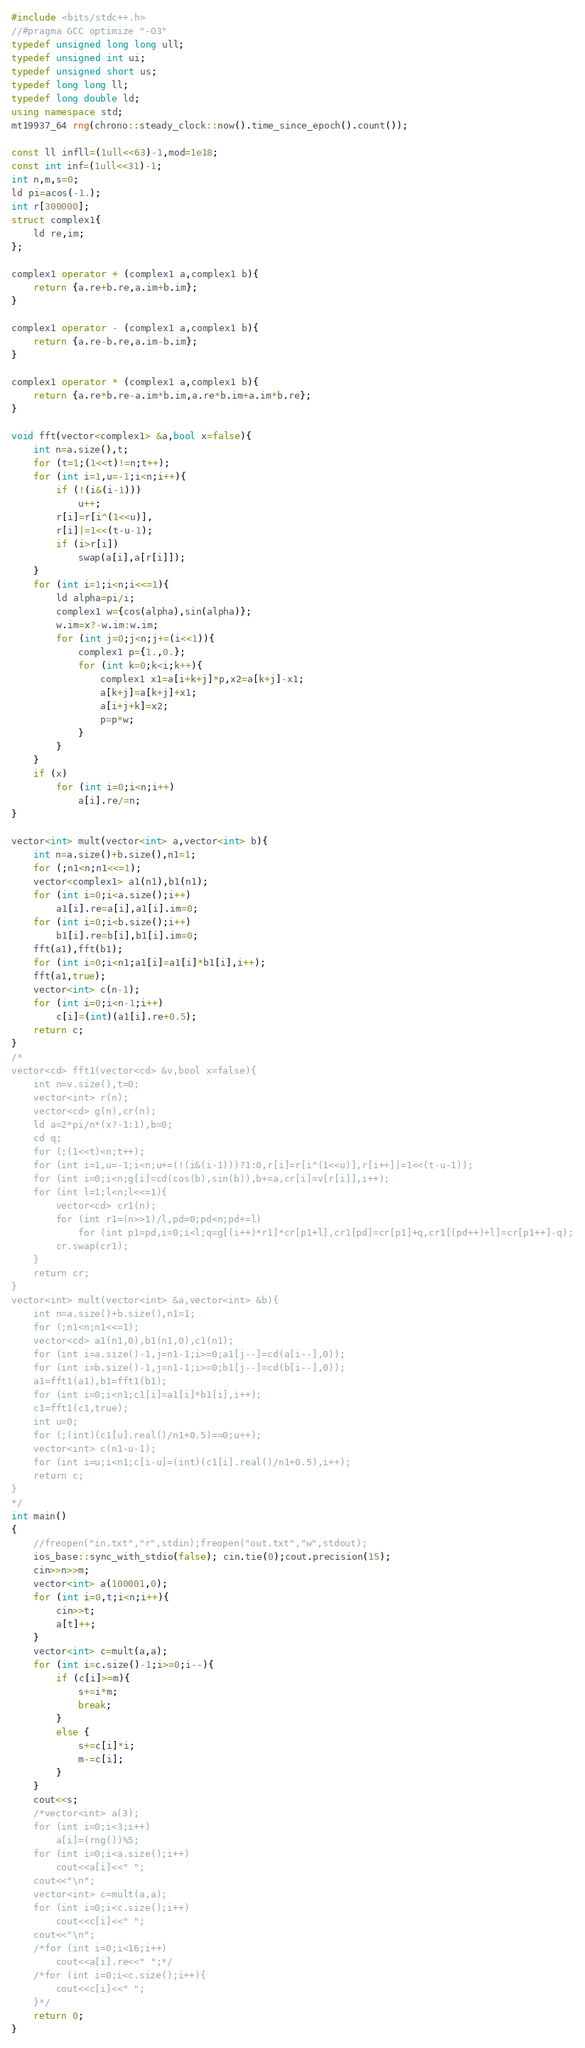Convert code to text. <code><loc_0><loc_0><loc_500><loc_500><_C++_>#include <bits/stdc++.h>
//#pragma GCC optimize "-O3"
typedef unsigned long long ull;
typedef unsigned int ui;
typedef unsigned short us;
typedef long long ll;
typedef long double ld;
using namespace std;
mt19937_64 rng(chrono::steady_clock::now().time_since_epoch().count());

const ll infll=(1ull<<63)-1,mod=1e18;
const int inf=(1ull<<31)-1;
int n,m,s=0;
ld pi=acos(-1.);
int r[300000];
struct complex1{
	ld re,im;
};

complex1 operator + (complex1 a,complex1 b){
	return {a.re+b.re,a.im+b.im};
}

complex1 operator - (complex1 a,complex1 b){
	return {a.re-b.re,a.im-b.im};
}

complex1 operator * (complex1 a,complex1 b){
	return {a.re*b.re-a.im*b.im,a.re*b.im+a.im*b.re};
}

void fft(vector<complex1> &a,bool x=false){
	int n=a.size(),t;
	for (t=1;(1<<t)!=n;t++);
	for (int i=1,u=-1;i<n;i++){
		if (!(i&(i-1)))
			u++;
		r[i]=r[i^(1<<u)],
		r[i]|=1<<(t-u-1);
		if (i>r[i])
			swap(a[i],a[r[i]]);
	}
	for (int i=1;i<n;i<<=1){
		ld alpha=pi/i;
		complex1 w={cos(alpha),sin(alpha)};
		w.im=x?-w.im:w.im;
		for (int j=0;j<n;j+=(i<<1)){
			complex1 p={1.,0.};
			for (int k=0;k<i;k++){
				complex1 x1=a[i+k+j]*p,x2=a[k+j]-x1;
				a[k+j]=a[k+j]+x1;
				a[i+j+k]=x2;
				p=p*w;
			}
		}
	}
	if (x)
		for (int i=0;i<n;i++)
			a[i].re/=n;
}

vector<int> mult(vector<int> a,vector<int> b){
	int n=a.size()+b.size(),n1=1;
	for (;n1<n;n1<<=1);
	vector<complex1> a1(n1),b1(n1);
	for (int i=0;i<a.size();i++)
		a1[i].re=a[i],a1[i].im=0;
	for (int i=0;i<b.size();i++)
		b1[i].re=b[i],b1[i].im=0;
	fft(a1),fft(b1);
	for (int i=0;i<n1;a1[i]=a1[i]*b1[i],i++);
	fft(a1,true);
	vector<int> c(n-1);
	for (int i=0;i<n-1;i++)
		c[i]=(int)(a1[i].re+0.5);
	return c;
}
/*
vector<cd> fft1(vector<cd> &v,bool x=false){
	int n=v.size(),t=0;
	vector<int> r(n);
	vector<cd> g(n),cr(n);
    ld a=2*pi/n*(x?-1:1),b=0;
    cd q;
	for (;(1<<t)<n;t++);
	for (int i=1,u=-1;i<n;u+=(!(i&(i-1)))?1:0,r[i]=r[i^(1<<u)],r[i++]|=1<<(t-u-1));
    for (int i=0;i<n;g[i]=cd(cos(b),sin(b)),b+=a,cr[i]=v[r[i]],i++);
    for (int l=1;l<n;l<<=1){
    	vector<cd> cr1(n);
    	for (int r1=(n>>1)/l,pd=0;pd<n;pd+=l)
    		for (int p1=pd,i=0;i<l;q=g[(i++)*r1]*cr[p1+l],cr1[pd]=cr[p1]+q,cr1[(pd++)+l]=cr[p1++]-q);
    	cr.swap(cr1);
    }
    return cr;
}
vector<int> mult(vector<int> &a,vector<int> &b){
	int n=a.size()+b.size(),n1=1;
	for (;n1<n;n1<<=1);
	vector<cd> a1(n1,0),b1(n1,0),c1(n1);
	for (int i=a.size()-1,j=n1-1;i>=0;a1[j--]=cd(a[i--],0));
	for (int i=b.size()-1,j=n1-1;i>=0;b1[j--]=cd(b[i--],0));
	a1=fft1(a1),b1=fft1(b1);
	for (int i=0;i<n1;c1[i]=a1[i]*b1[i],i++);
	c1=fft1(c1,true);
	int u=0; 
	for (;(int)(c1[u].real()/n1+0.5)==0;u++);
	vector<int> c(n1-u-1);
	for (int i=u;i<n1;c[i-u]=(int)(c1[i].real()/n1+0.5),i++);
	return c;
}
*/
int main()
{
	//freopen("in.txt","r",stdin);freopen("out.txt","w",stdout);
	ios_base::sync_with_stdio(false); cin.tie(0);cout.precision(15);
	cin>>n>>m;
	vector<int> a(100001,0);
	for (int i=0,t;i<n;i++){
		cin>>t;
		a[t]++;
	}
	vector<int> c=mult(a,a);
	for (int i=c.size()-1;i>=0;i--){
		if (c[i]>=m){
			s+=i*m;
			break;
		}
		else {
			s+=c[i]*i;
			m-=c[i];
		}
	}
	cout<<s;
	/*vector<int> a(3);
	for (int i=0;i<3;i++)
		a[i]=(rng())%5;
	for (int i=0;i<a.size();i++)
		cout<<a[i]<<" ";
	cout<<"\n";
	vector<int> c=mult(a,a);
	for (int i=0;i<c.size();i++)
		cout<<c[i]<<" ";
	cout<<"\n";
	/*for (int i=0;i<16;i++)
		cout<<a[i].re<<" ";*/
	/*for (int i=0;i<c.size();i++){
		cout<<c[i]<<" ";
	}*/
	return 0;
}</code> 